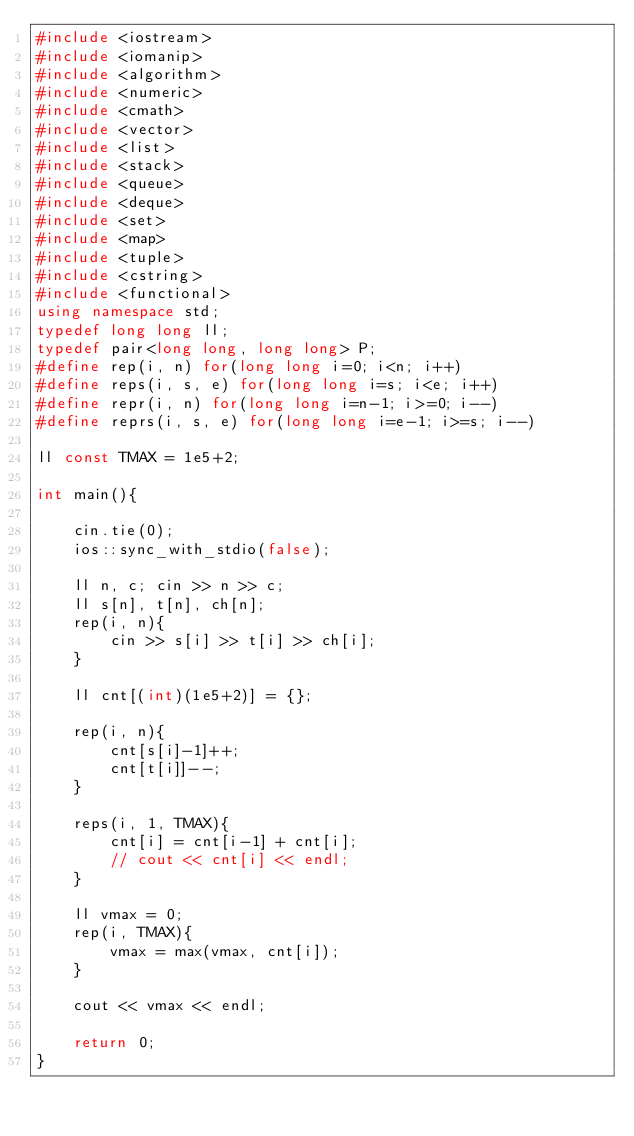<code> <loc_0><loc_0><loc_500><loc_500><_C++_>#include <iostream>
#include <iomanip>
#include <algorithm>
#include <numeric>
#include <cmath>
#include <vector>
#include <list>
#include <stack>
#include <queue>
#include <deque>
#include <set>
#include <map>
#include <tuple>
#include <cstring>
#include <functional>
using namespace std;
typedef long long ll;
typedef pair<long long, long long> P;
#define rep(i, n) for(long long i=0; i<n; i++)
#define reps(i, s, e) for(long long i=s; i<e; i++)
#define repr(i, n) for(long long i=n-1; i>=0; i--)
#define reprs(i, s, e) for(long long i=e-1; i>=s; i--)

ll const TMAX = 1e5+2;

int main(){

    cin.tie(0);
    ios::sync_with_stdio(false);

    ll n, c; cin >> n >> c;
    ll s[n], t[n], ch[n];
    rep(i, n){
        cin >> s[i] >> t[i] >> ch[i];
    }

    ll cnt[(int)(1e5+2)] = {};

    rep(i, n){
        cnt[s[i]-1]++;
        cnt[t[i]]--;
    }

    reps(i, 1, TMAX){
        cnt[i] = cnt[i-1] + cnt[i];
        // cout << cnt[i] << endl;
    }

    ll vmax = 0;
    rep(i, TMAX){
        vmax = max(vmax, cnt[i]);
    }

    cout << vmax << endl;

    return 0;
}</code> 